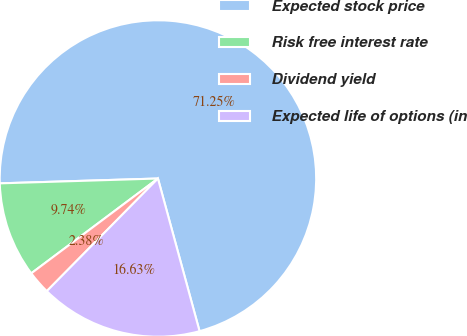<chart> <loc_0><loc_0><loc_500><loc_500><pie_chart><fcel>Expected stock price<fcel>Risk free interest rate<fcel>Dividend yield<fcel>Expected life of options (in<nl><fcel>71.26%<fcel>9.74%<fcel>2.38%<fcel>16.63%<nl></chart> 